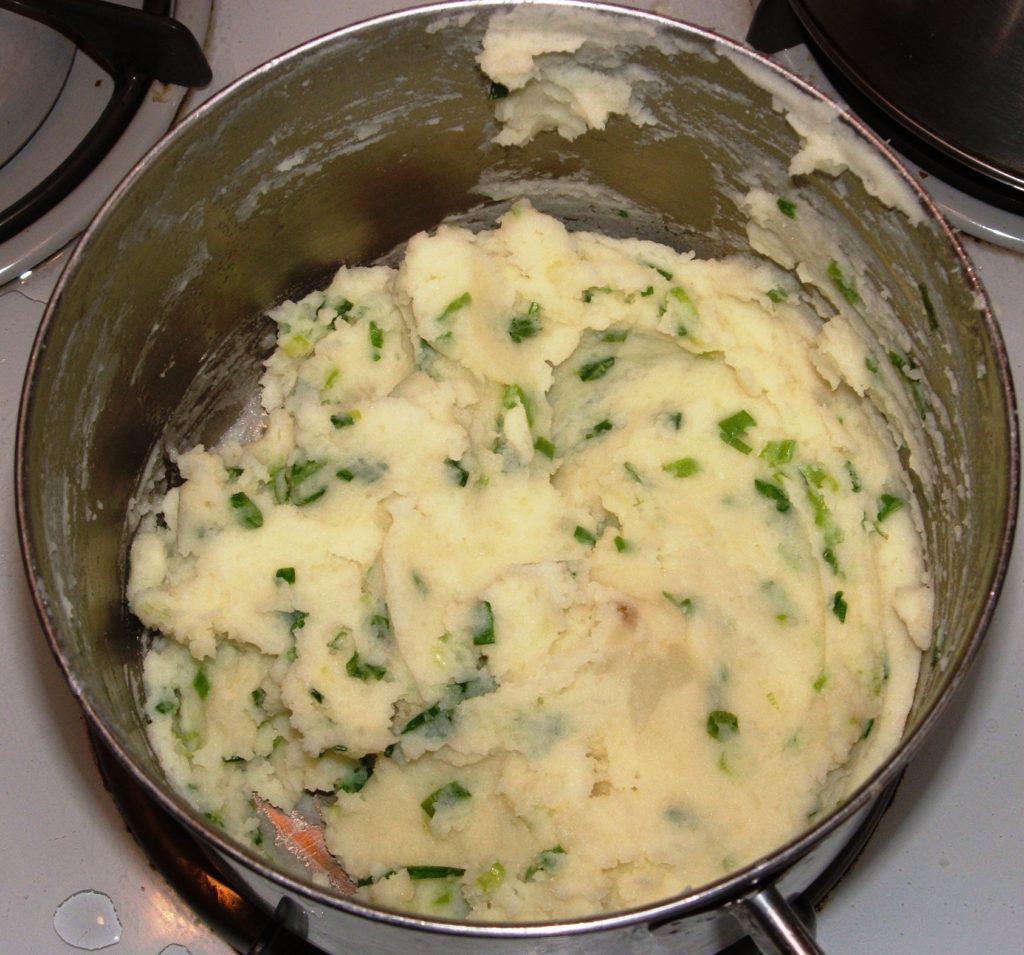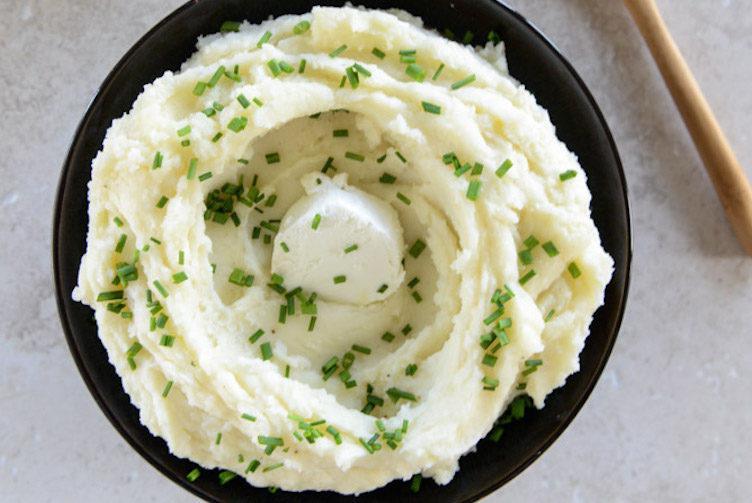The first image is the image on the left, the second image is the image on the right. For the images shown, is this caption "One piece of silverware is in a dish that contains something resembling mashed potatoes." true? Answer yes or no. No. The first image is the image on the left, the second image is the image on the right. Evaluate the accuracy of this statement regarding the images: "There is a utensil adjacent to the mashed potatoes.". Is it true? Answer yes or no. No. 